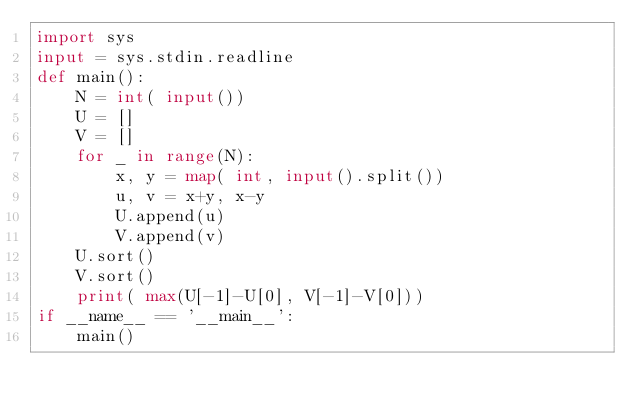<code> <loc_0><loc_0><loc_500><loc_500><_Python_>import sys
input = sys.stdin.readline
def main():
    N = int( input())
    U = []
    V = []
    for _ in range(N):
        x, y = map( int, input().split())
        u, v = x+y, x-y
        U.append(u)
        V.append(v)
    U.sort()
    V.sort()
    print( max(U[-1]-U[0], V[-1]-V[0]))
if __name__ == '__main__':
    main()
</code> 